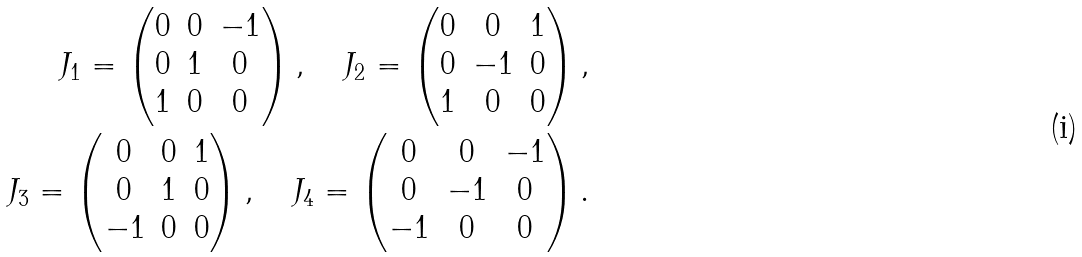<formula> <loc_0><loc_0><loc_500><loc_500>J _ { 1 } = \begin{pmatrix} 0 & 0 & - 1 \\ 0 & 1 & 0 \\ 1 & 0 & 0 \end{pmatrix} , \quad J _ { 2 } = \begin{pmatrix} 0 & 0 & 1 \\ 0 & - 1 & 0 \\ 1 & 0 & 0 \end{pmatrix} , \\ J _ { 3 } = \begin{pmatrix} 0 & 0 & 1 \\ 0 & 1 & 0 \\ - 1 & 0 & 0 \end{pmatrix} , \quad J _ { 4 } = \begin{pmatrix} 0 & 0 & - 1 \\ 0 & - 1 & 0 \\ - 1 & 0 & 0 \end{pmatrix} .</formula> 